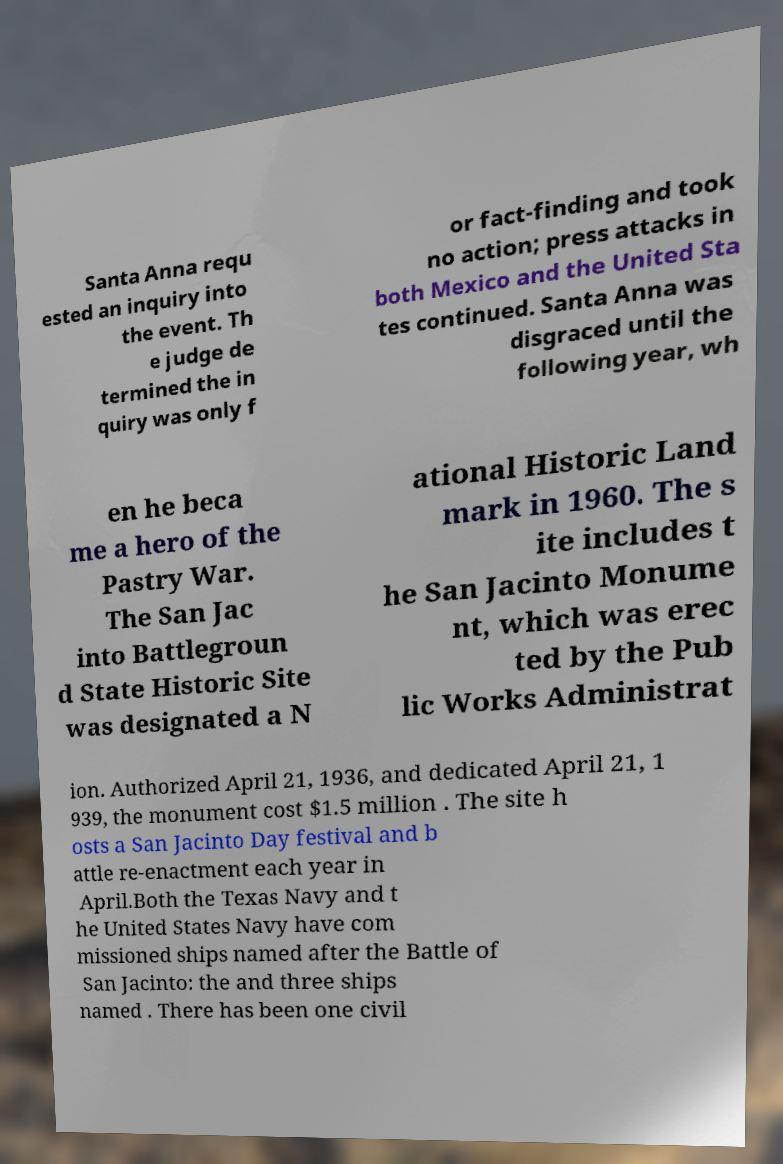Could you assist in decoding the text presented in this image and type it out clearly? Santa Anna requ ested an inquiry into the event. Th e judge de termined the in quiry was only f or fact-finding and took no action; press attacks in both Mexico and the United Sta tes continued. Santa Anna was disgraced until the following year, wh en he beca me a hero of the Pastry War. The San Jac into Battlegroun d State Historic Site was designated a N ational Historic Land mark in 1960. The s ite includes t he San Jacinto Monume nt, which was erec ted by the Pub lic Works Administrat ion. Authorized April 21, 1936, and dedicated April 21, 1 939, the monument cost $1.5 million . The site h osts a San Jacinto Day festival and b attle re-enactment each year in April.Both the Texas Navy and t he United States Navy have com missioned ships named after the Battle of San Jacinto: the and three ships named . There has been one civil 